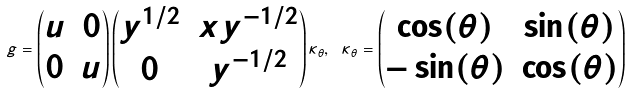<formula> <loc_0><loc_0><loc_500><loc_500>g = \begin{pmatrix} u & 0 \\ 0 & u \\ \end{pmatrix} \begin{pmatrix} y ^ { 1 / 2 } & x y ^ { - 1 / 2 } \\ 0 & y ^ { - 1 / 2 } \\ \end{pmatrix} \kappa _ { \theta } , \ \kappa _ { \theta } = \begin{pmatrix} \cos ( \theta ) & \sin ( \theta ) \\ - \sin ( \theta ) & \cos ( \theta ) \\ \end{pmatrix}</formula> 